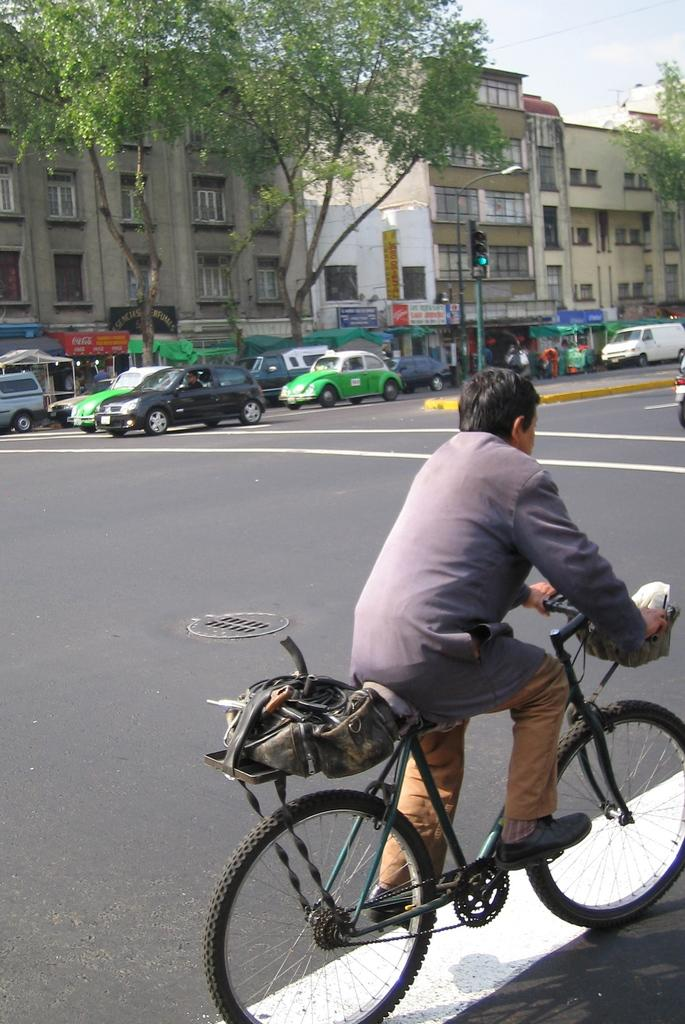What is the man in the image doing? The man is riding a bicycle in the image. Where is the man riding the bicycle? The man is on the road. What can be seen in the background of the image? Cars, trees, buildings, and poles are visible in the background of the image. What is the goat's opinion on the texture of the road in the image? There is no goat present in the image, and therefore it cannot have an opinion on the texture of the road. 